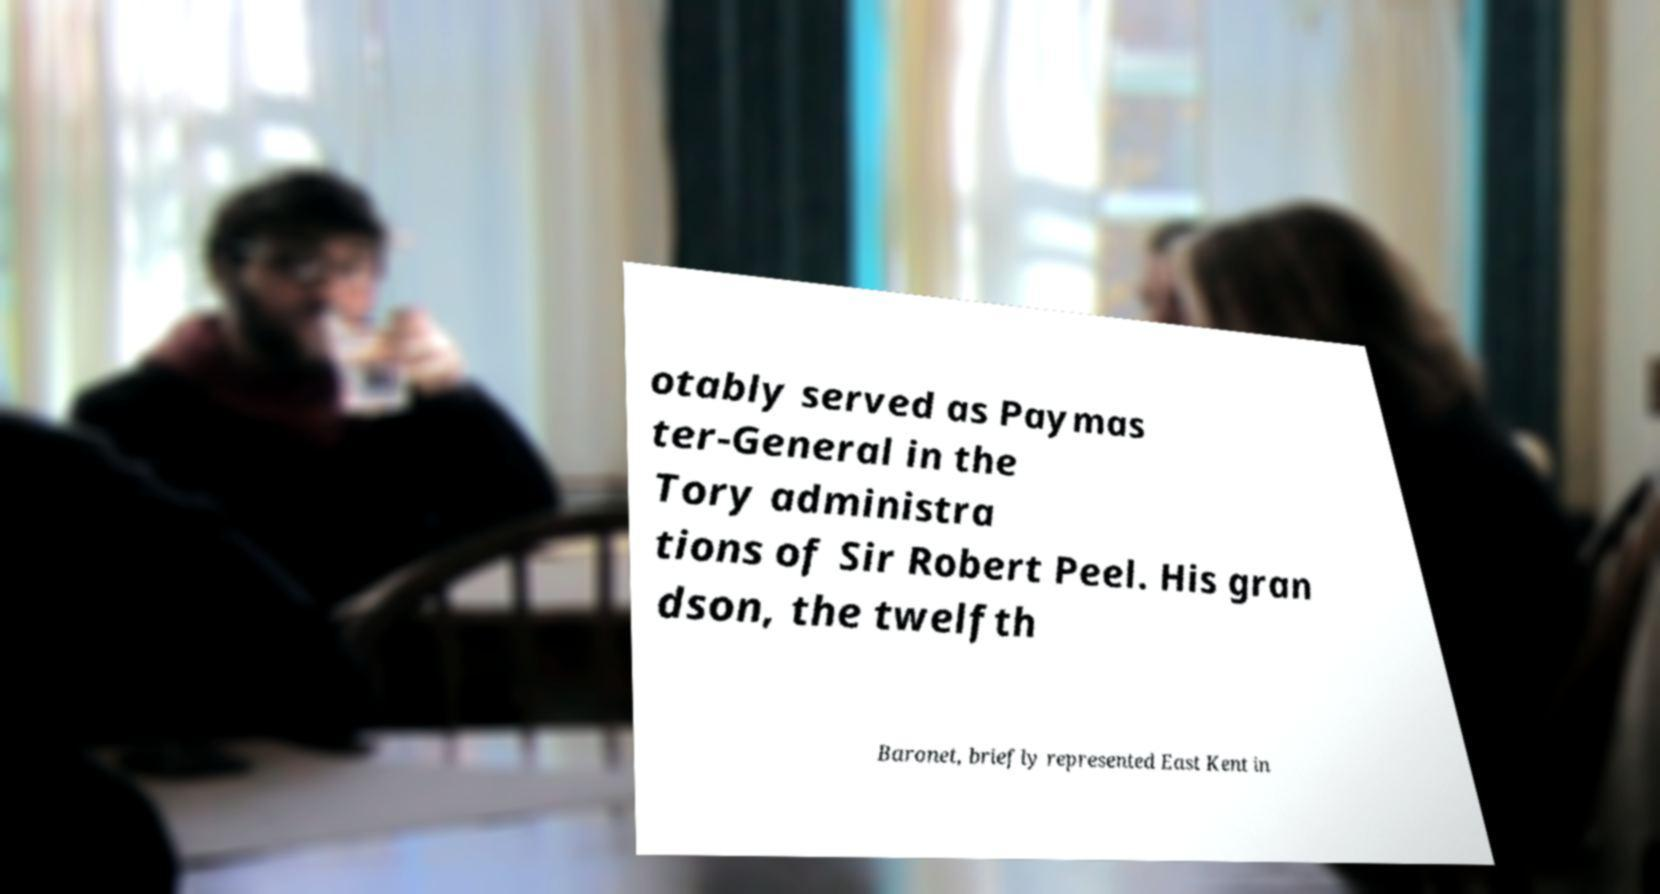There's text embedded in this image that I need extracted. Can you transcribe it verbatim? otably served as Paymas ter-General in the Tory administra tions of Sir Robert Peel. His gran dson, the twelfth Baronet, briefly represented East Kent in 